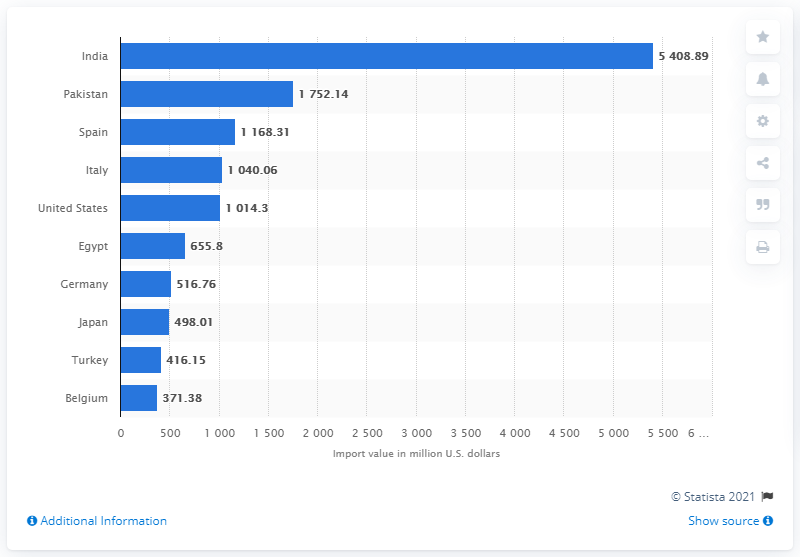Outline some significant characteristics in this image. In 2019, the import value of palm oil was 5408.89. 